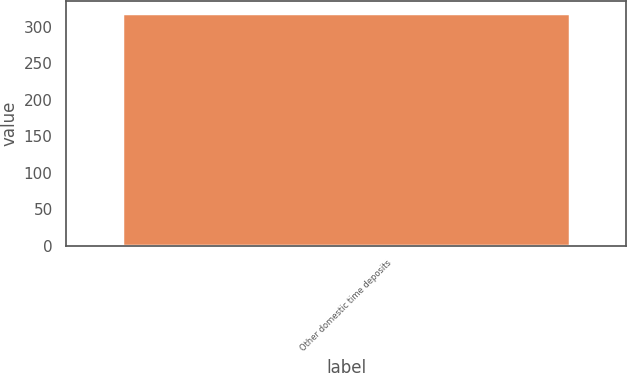Convert chart to OTSL. <chart><loc_0><loc_0><loc_500><loc_500><bar_chart><fcel>Other domestic time deposits<nl><fcel>319<nl></chart> 